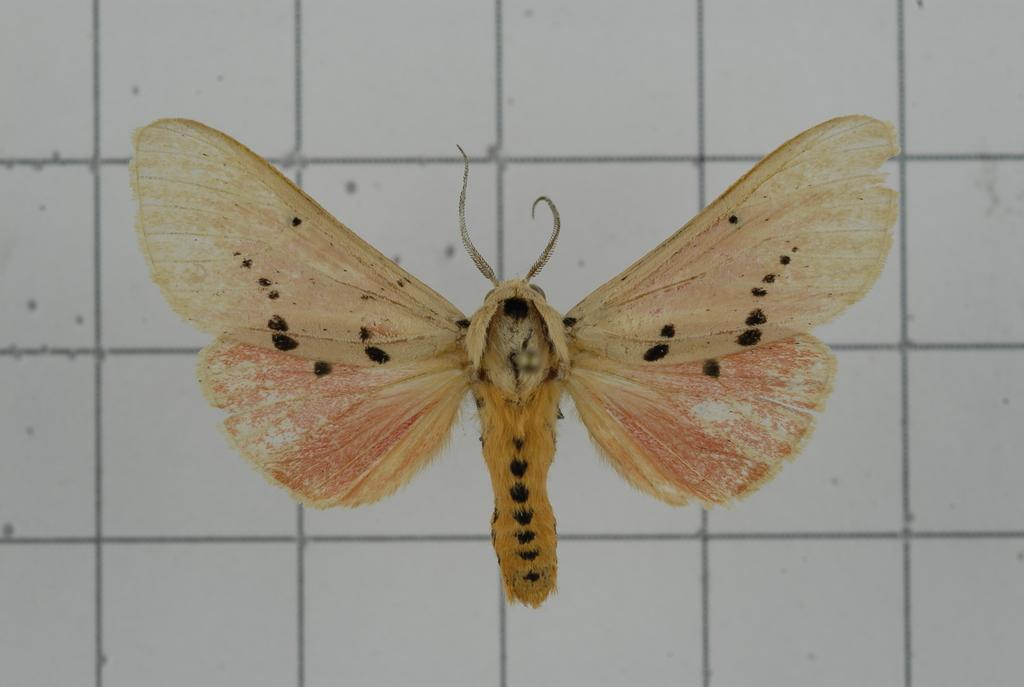What is the main subject of the picture? The main subject of the picture is a butterfly. Can you describe the color of the butterfly? The butterfly is brown and cream in color. What can be seen in the background of the picture? There is a wall with lines in the background of the picture. How many ducks are sitting on the plant in the image? There are no ducks or plants present in the image; it features a brown and cream butterfly against a background with lines. 